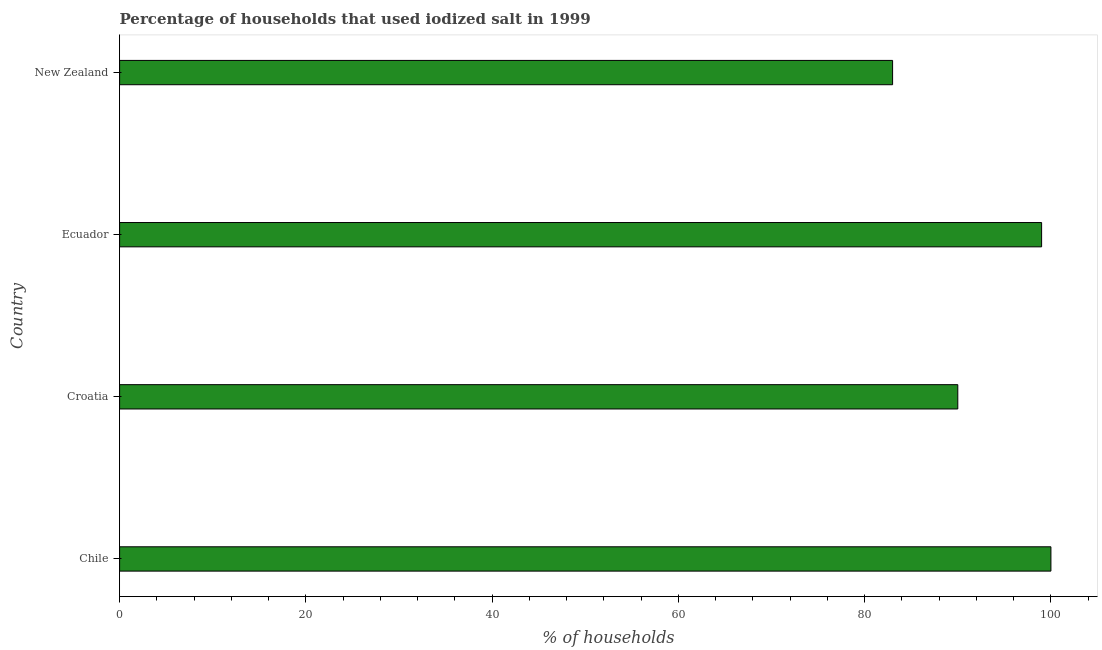Does the graph contain any zero values?
Offer a terse response. No. What is the title of the graph?
Ensure brevity in your answer.  Percentage of households that used iodized salt in 1999. What is the label or title of the X-axis?
Provide a succinct answer. % of households. What is the label or title of the Y-axis?
Make the answer very short. Country. What is the percentage of households where iodized salt is consumed in Chile?
Your answer should be very brief. 100. Across all countries, what is the maximum percentage of households where iodized salt is consumed?
Make the answer very short. 100. Across all countries, what is the minimum percentage of households where iodized salt is consumed?
Offer a terse response. 83. In which country was the percentage of households where iodized salt is consumed maximum?
Make the answer very short. Chile. In which country was the percentage of households where iodized salt is consumed minimum?
Keep it short and to the point. New Zealand. What is the sum of the percentage of households where iodized salt is consumed?
Ensure brevity in your answer.  372. What is the difference between the percentage of households where iodized salt is consumed in Ecuador and New Zealand?
Your response must be concise. 16. What is the average percentage of households where iodized salt is consumed per country?
Provide a succinct answer. 93. What is the median percentage of households where iodized salt is consumed?
Your answer should be very brief. 94.5. In how many countries, is the percentage of households where iodized salt is consumed greater than 64 %?
Provide a short and direct response. 4. What is the ratio of the percentage of households where iodized salt is consumed in Chile to that in Ecuador?
Make the answer very short. 1.01. Is the sum of the percentage of households where iodized salt is consumed in Croatia and New Zealand greater than the maximum percentage of households where iodized salt is consumed across all countries?
Provide a short and direct response. Yes. How many bars are there?
Provide a succinct answer. 4. Are all the bars in the graph horizontal?
Give a very brief answer. Yes. What is the % of households of Chile?
Give a very brief answer. 100. What is the % of households in Croatia?
Offer a terse response. 90. What is the % of households in Ecuador?
Your response must be concise. 99. What is the difference between the % of households in Chile and Ecuador?
Keep it short and to the point. 1. What is the difference between the % of households in Croatia and Ecuador?
Provide a short and direct response. -9. What is the ratio of the % of households in Chile to that in Croatia?
Your answer should be very brief. 1.11. What is the ratio of the % of households in Chile to that in Ecuador?
Give a very brief answer. 1.01. What is the ratio of the % of households in Chile to that in New Zealand?
Provide a succinct answer. 1.21. What is the ratio of the % of households in Croatia to that in Ecuador?
Offer a very short reply. 0.91. What is the ratio of the % of households in Croatia to that in New Zealand?
Provide a short and direct response. 1.08. What is the ratio of the % of households in Ecuador to that in New Zealand?
Ensure brevity in your answer.  1.19. 